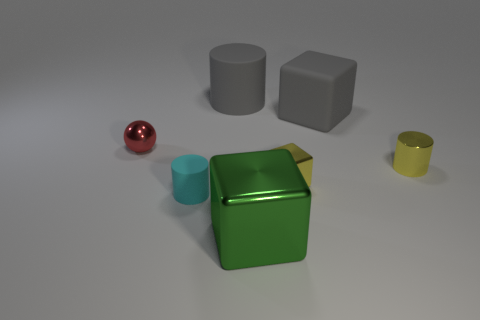Add 2 big matte things. How many objects exist? 9 Subtract all spheres. How many objects are left? 6 Subtract all big metal cubes. Subtract all tiny shiny balls. How many objects are left? 5 Add 1 big green metal blocks. How many big green metal blocks are left? 2 Add 3 big shiny objects. How many big shiny objects exist? 4 Subtract 1 gray cubes. How many objects are left? 6 